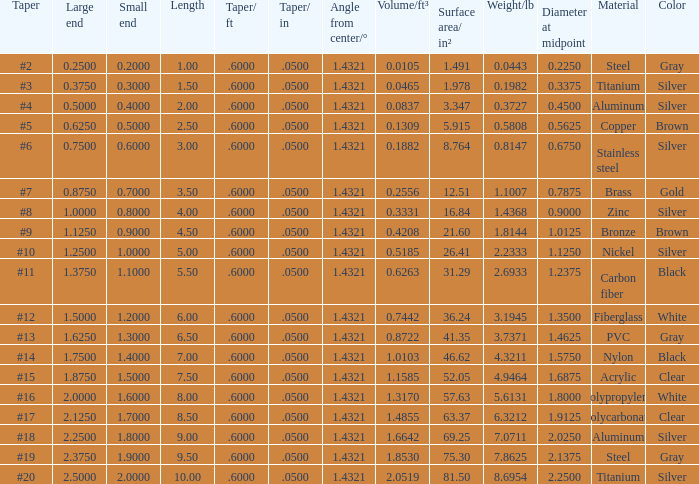What is the length of a taper with a #15 size and a large end exceeding 1.875 inches? None. 